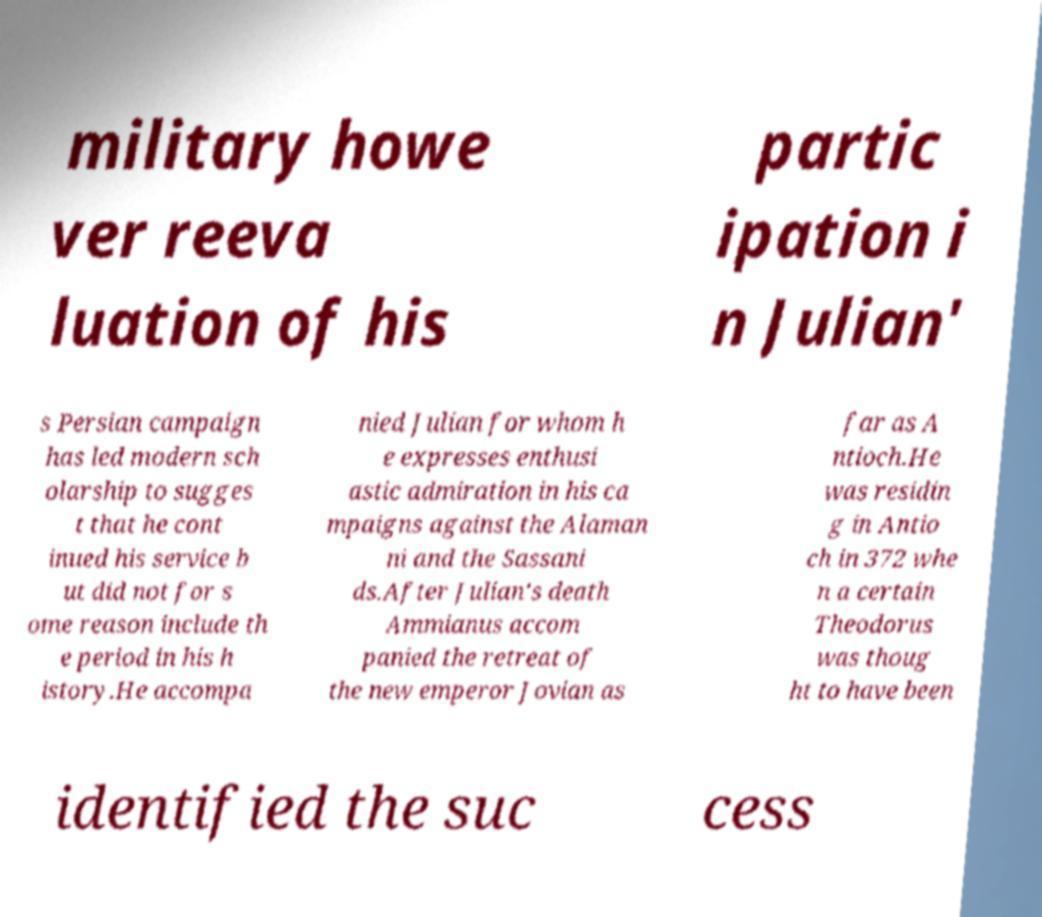There's text embedded in this image that I need extracted. Can you transcribe it verbatim? military howe ver reeva luation of his partic ipation i n Julian' s Persian campaign has led modern sch olarship to sugges t that he cont inued his service b ut did not for s ome reason include th e period in his h istory.He accompa nied Julian for whom h e expresses enthusi astic admiration in his ca mpaigns against the Alaman ni and the Sassani ds.After Julian's death Ammianus accom panied the retreat of the new emperor Jovian as far as A ntioch.He was residin g in Antio ch in 372 whe n a certain Theodorus was thoug ht to have been identified the suc cess 